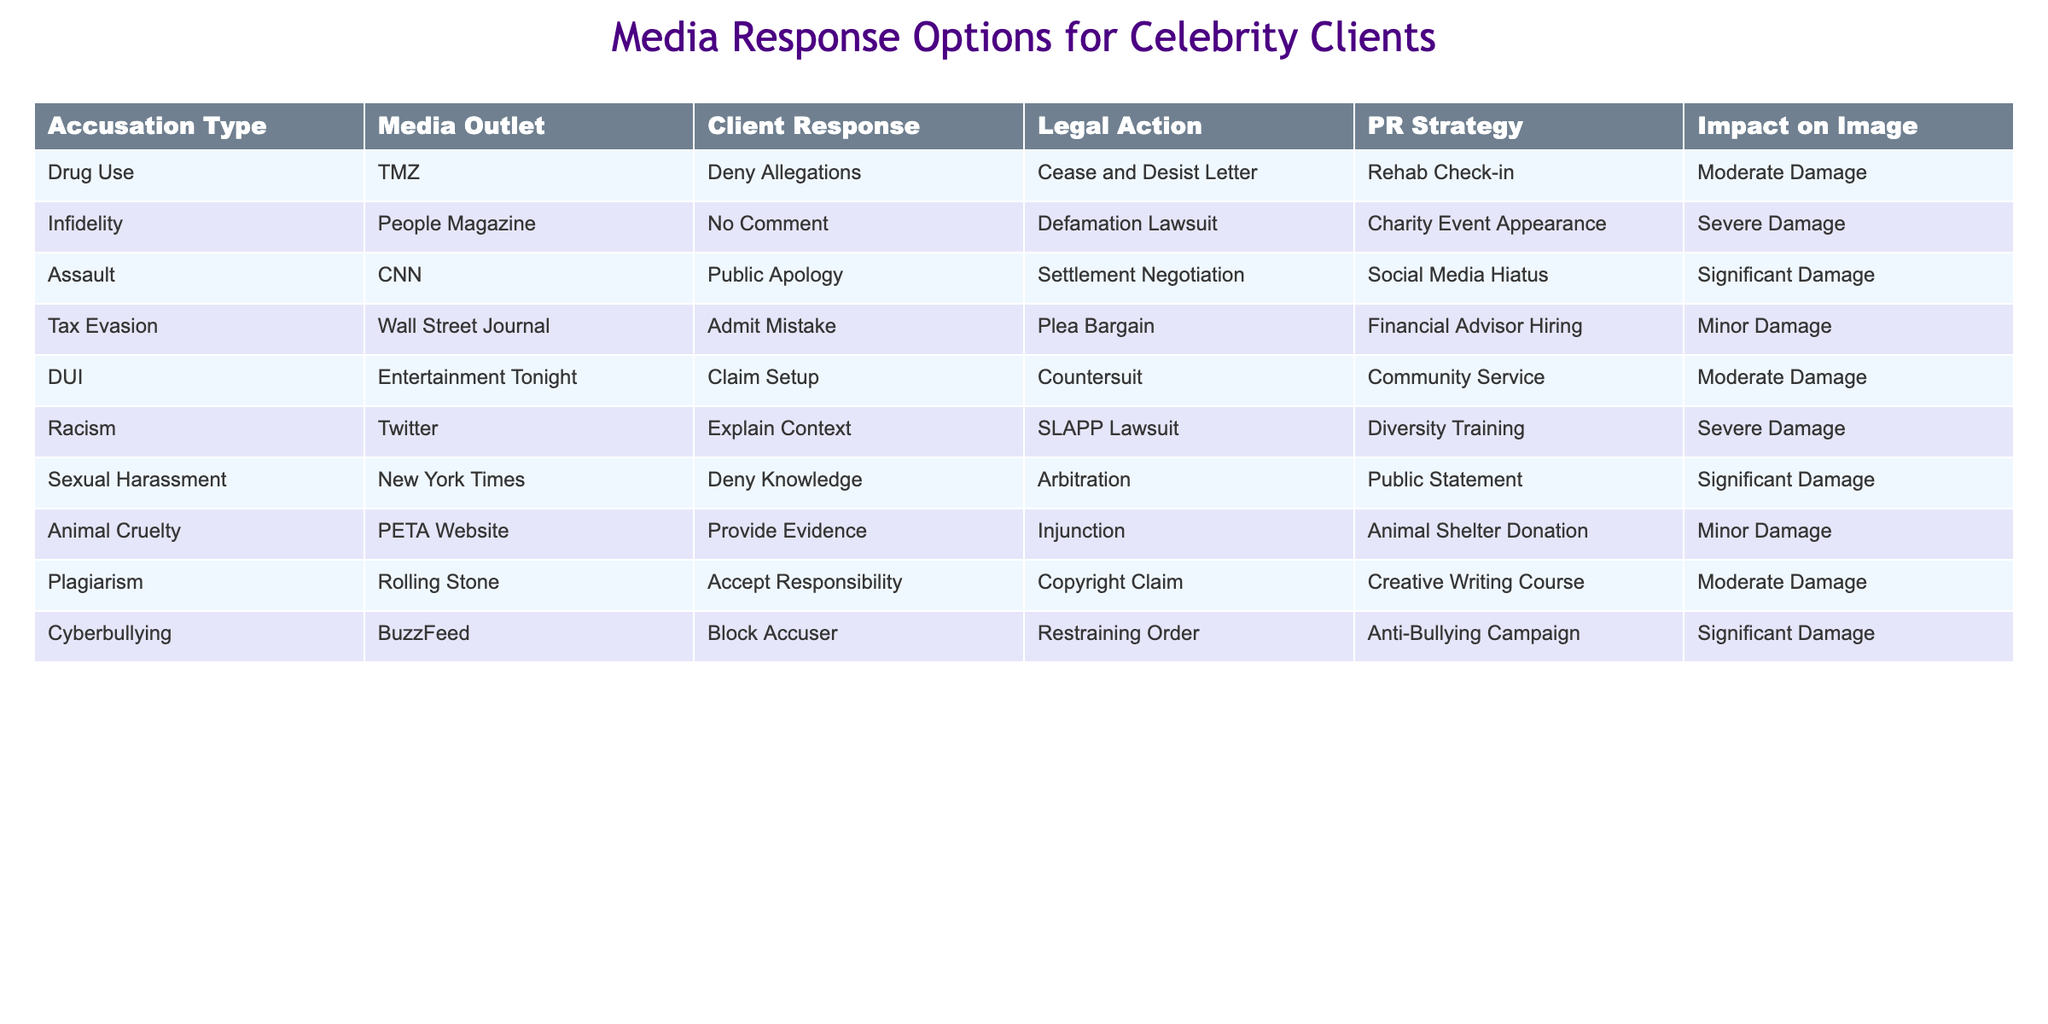What is the media outlet associated with the accusation of infidelity? The table lists "People Magazine" as the media outlet under the accusation type "Infidelity."
Answer: People Magazine Which client response corresponds to the accusation of animal cruelty? The table shows that the client response for "Animal Cruelty" is "Provide Evidence."
Answer: Provide Evidence How many different media outlets are represented in the table? The table includes eight unique media outlets: TMZ, People Magazine, CNN, Wall Street Journal, Entertainment Tonight, Twitter, New York Times, and PETA Website. This totals to 8 outlets.
Answer: 8 Is the impact on image for a DUI accusation moderate or severe? The table indicates that the impact on image for "DUI" is classified as "Moderate Damage."
Answer: Moderate Damage What is the common legal action taken for assault allegations? According to the table, the common legal action for "Assault" is "Settlement Negotiation."
Answer: Settlement Negotiation What is the difference in impact on image between racism and sexual harassment accusations? The impact on image for "Racism" is "Severe Damage," while for "Sexual Harassment," it is "Significant Damage." The difference between "Severe" and "Significant" indicates that racism has a greater potential for damage.
Answer: Racism has greater potential for damage Which PR strategy is mentioned for the accusation of tax evasion? The table indicates that the PR strategy for "Tax Evasion" is to hire a "Financial Advisor."
Answer: Financial Advisor Hiring If a celebrity denies knowledge in response to a sexual harassment accusation, what is their media response? The table shows that for the accusation of "Sexual Harassment," the client response is "Deny Knowledge."
Answer: Deny Knowledge For how many accusations is the PR strategy a community service? The table lists "Community Service" as the PR strategy for only one accusation, which is "DUI." Therefore, the count is 1.
Answer: 1 